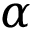Convert formula to latex. <formula><loc_0><loc_0><loc_500><loc_500>\alpha</formula> 